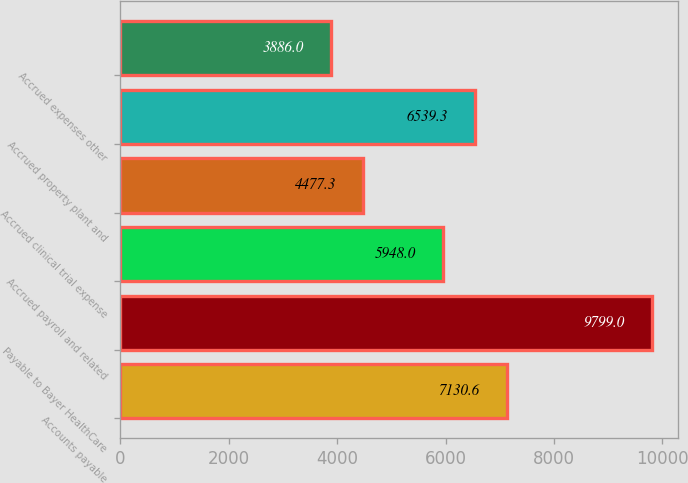<chart> <loc_0><loc_0><loc_500><loc_500><bar_chart><fcel>Accounts payable<fcel>Payable to Bayer HealthCare<fcel>Accrued payroll and related<fcel>Accrued clinical trial expense<fcel>Accrued property plant and<fcel>Accrued expenses other<nl><fcel>7130.6<fcel>9799<fcel>5948<fcel>4477.3<fcel>6539.3<fcel>3886<nl></chart> 